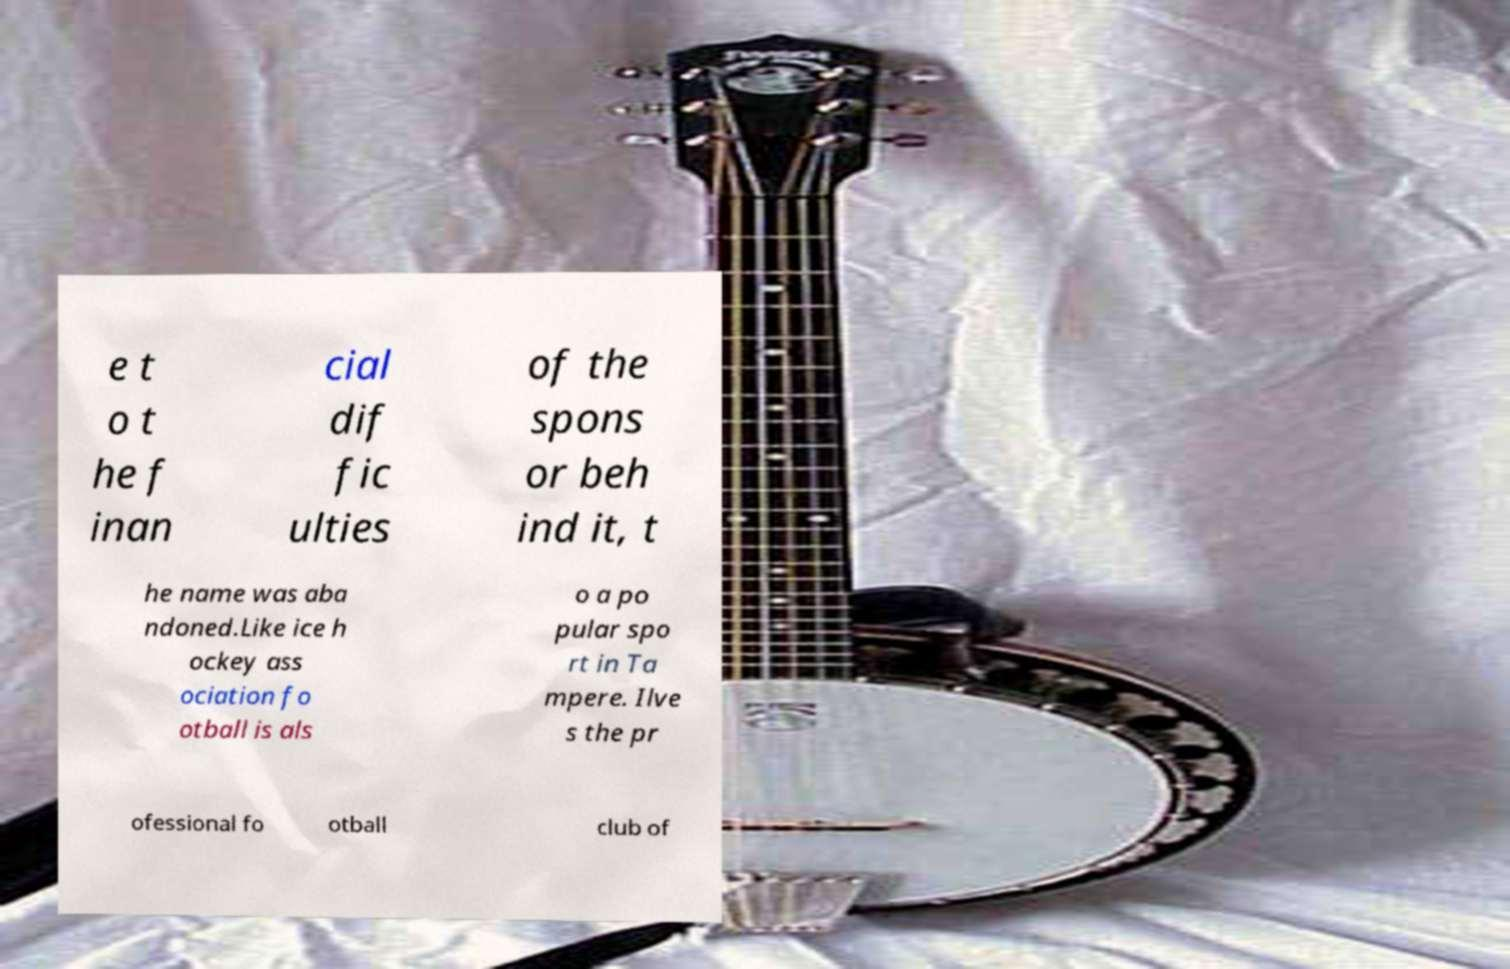There's text embedded in this image that I need extracted. Can you transcribe it verbatim? e t o t he f inan cial dif fic ulties of the spons or beh ind it, t he name was aba ndoned.Like ice h ockey ass ociation fo otball is als o a po pular spo rt in Ta mpere. Ilve s the pr ofessional fo otball club of 